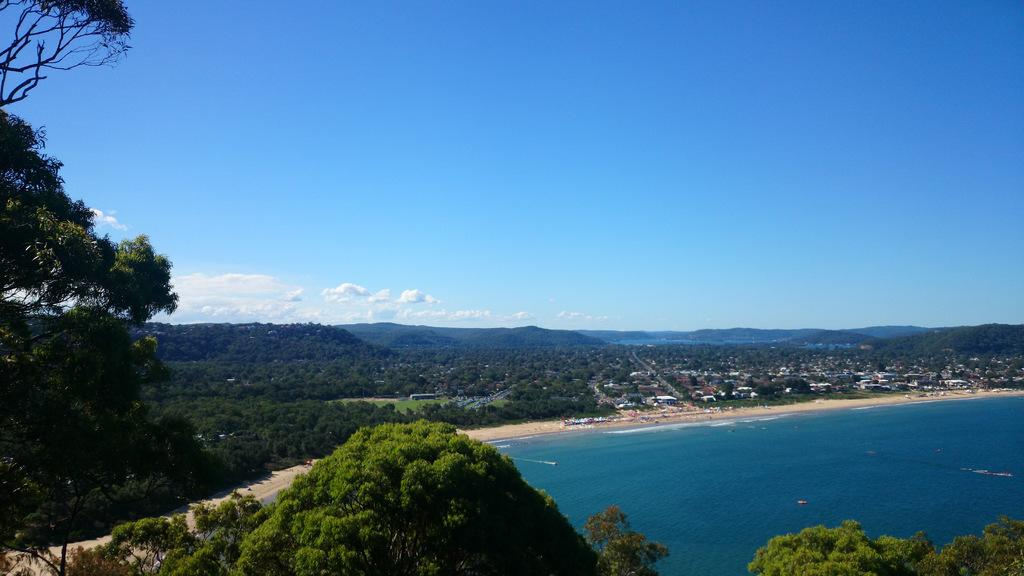What type of vegetation is present at the bottom of the image? There are trees at the bottom of the image. What can be seen in the background of the image? Water, houses, trees, hills, and the sky are visible in the background of the image. How many girls are sitting on the linen in the image? There are no girls or linen present in the image. 